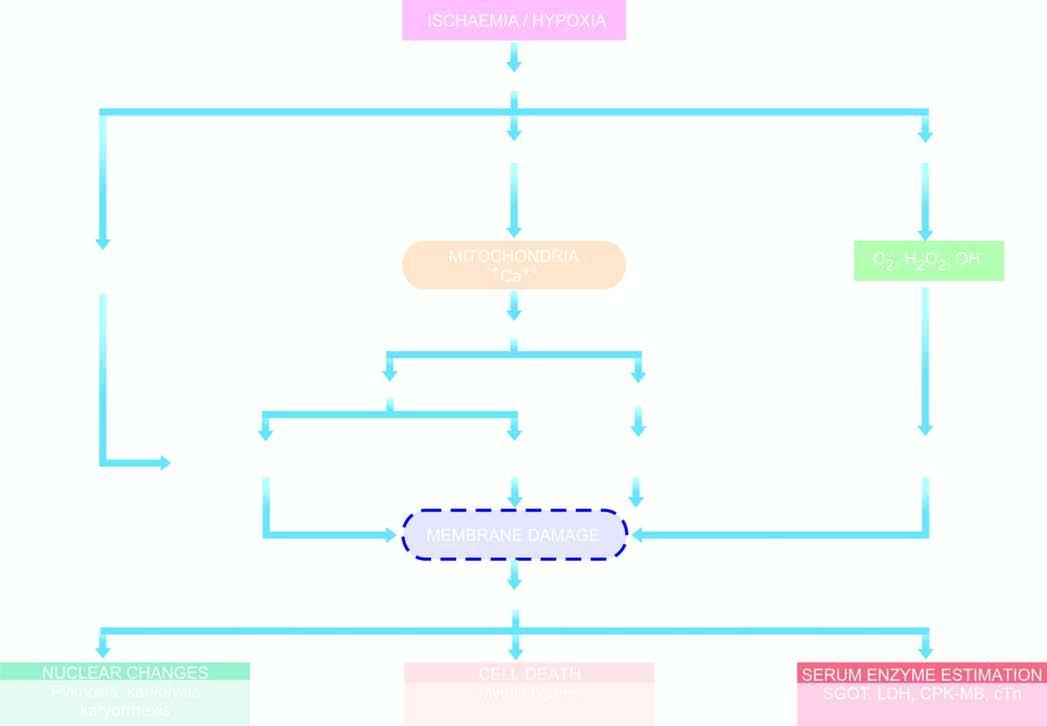s equence of events in the pathogenesis of reversible and irreversible cell injury caused by hypoxia/ischaemia?
Answer the question using a single word or phrase. Yes 